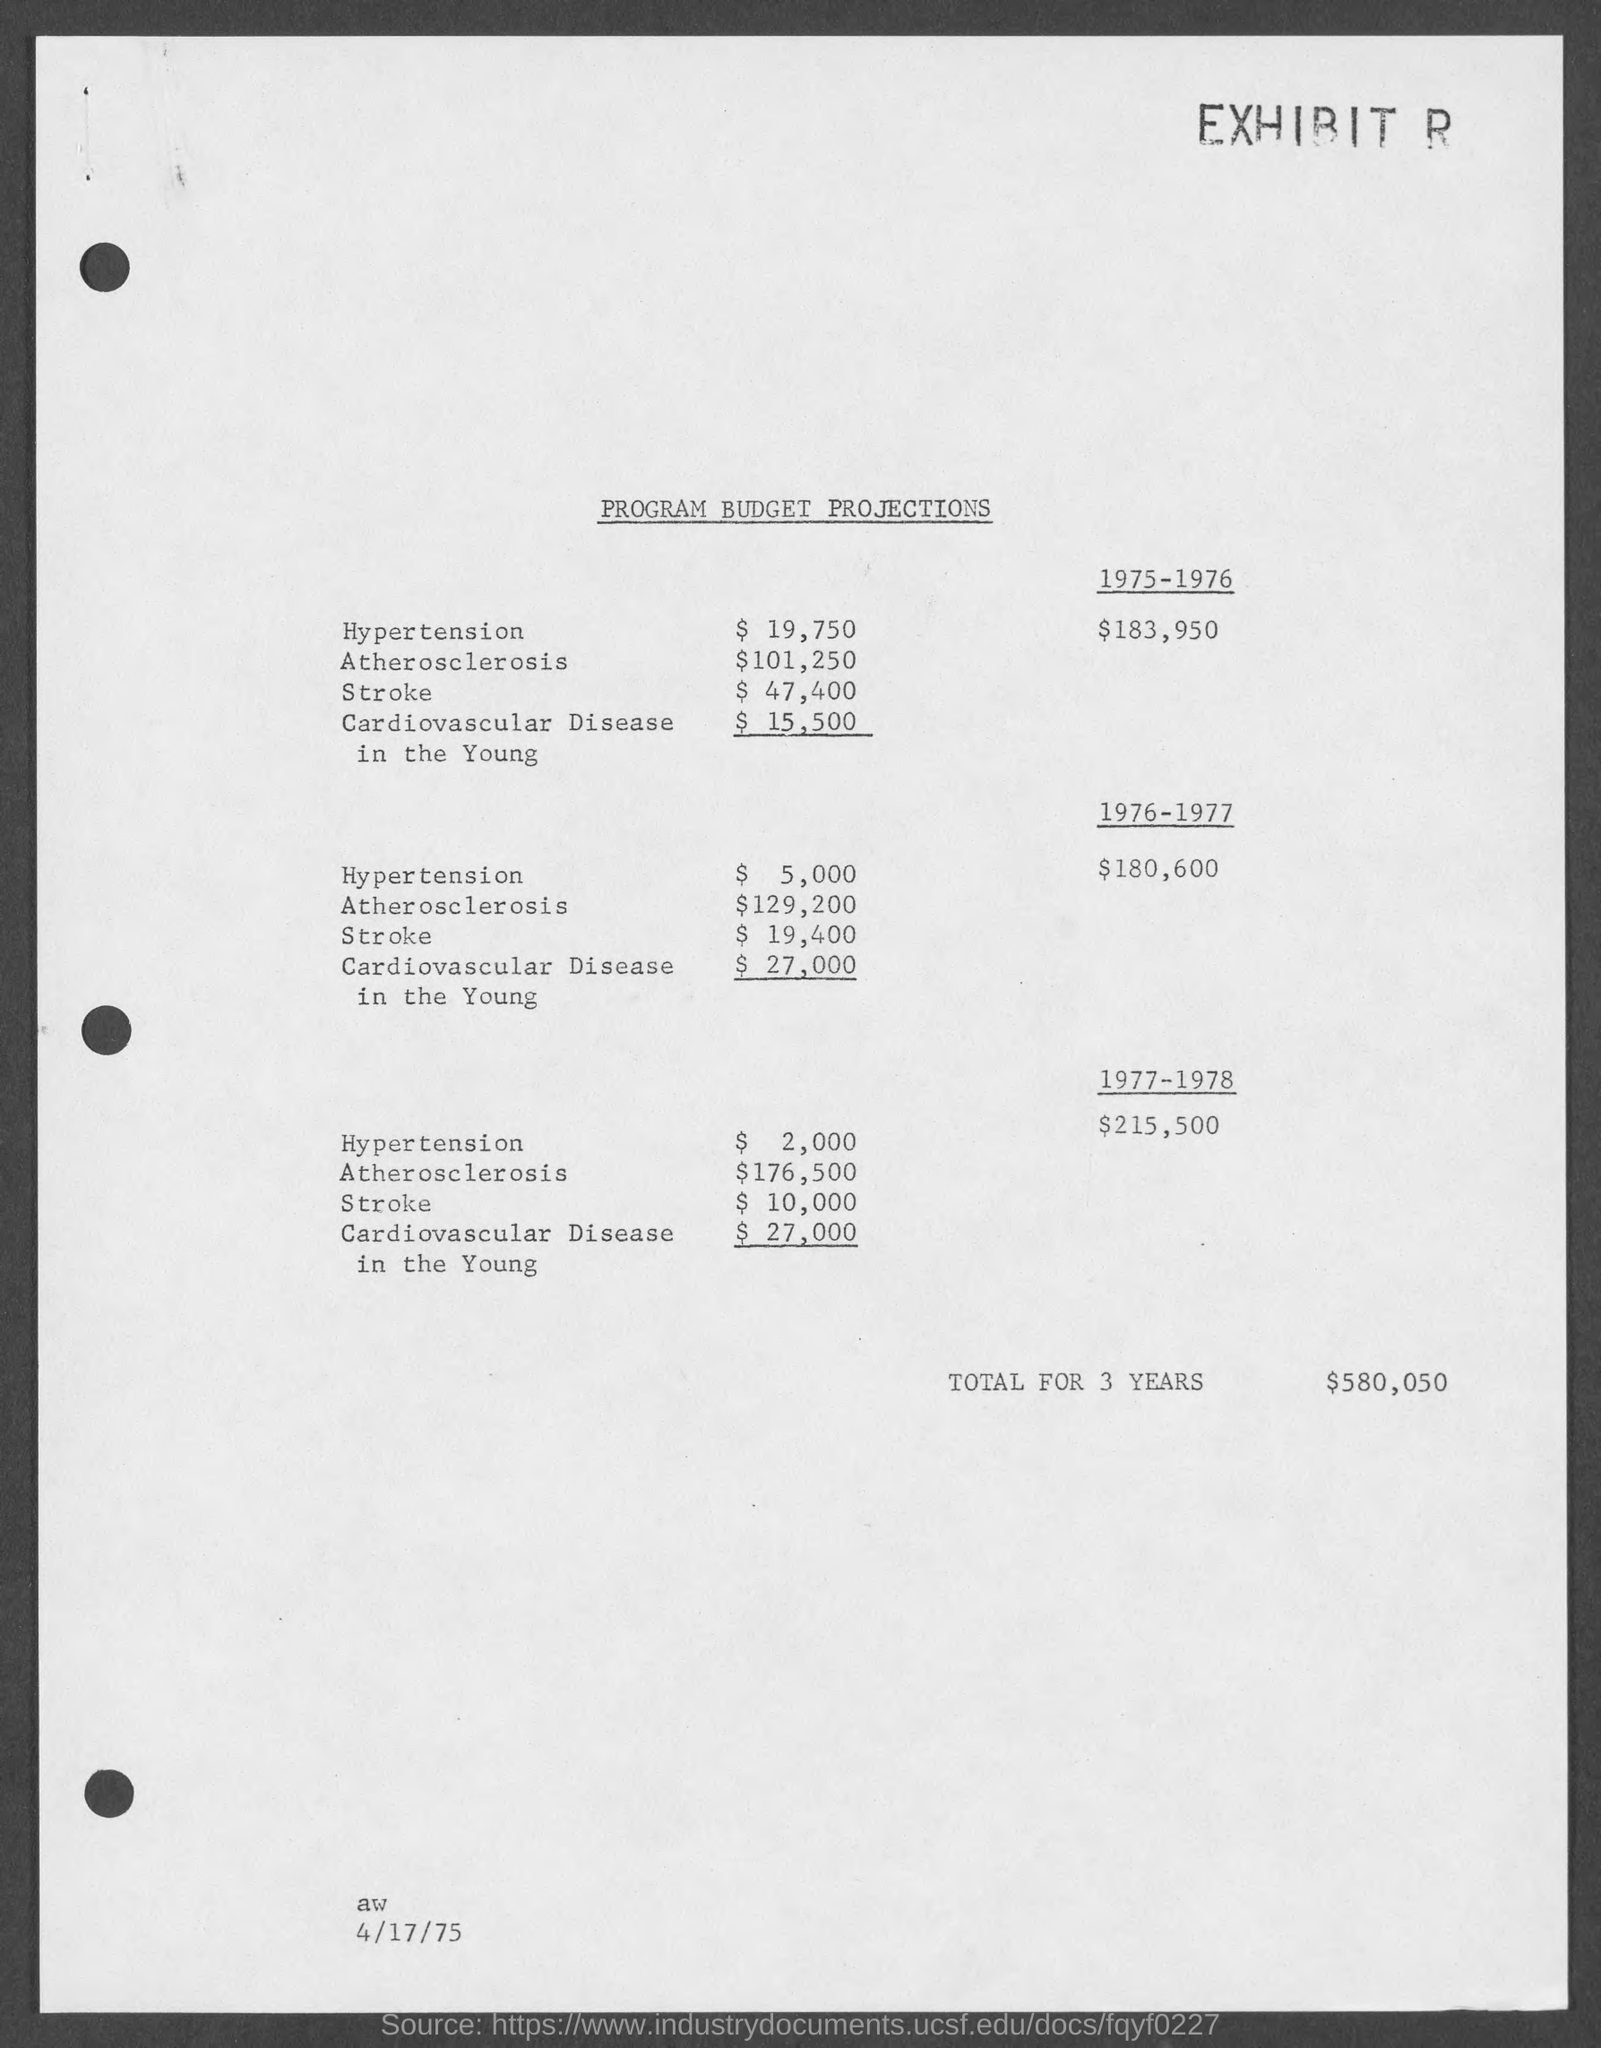What is the document title?
Give a very brief answer. Program budget projections. When is the document dated?
Provide a succinct answer. 4/17/75. What is the total for 3 years?
Give a very brief answer. $580,050. 